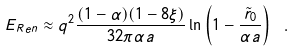<formula> <loc_0><loc_0><loc_500><loc_500>E _ { R e n } \approx q ^ { 2 } \frac { ( 1 - \alpha ) ( 1 - 8 \xi ) } { 3 2 \pi \alpha a } \ln \left ( 1 - \frac { \tilde { r } _ { 0 } } { \alpha a } \right ) \ .</formula> 